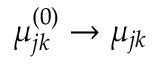<formula> <loc_0><loc_0><loc_500><loc_500>\mu _ { j k } ^ { ( 0 ) } \to \mu _ { j k }</formula> 